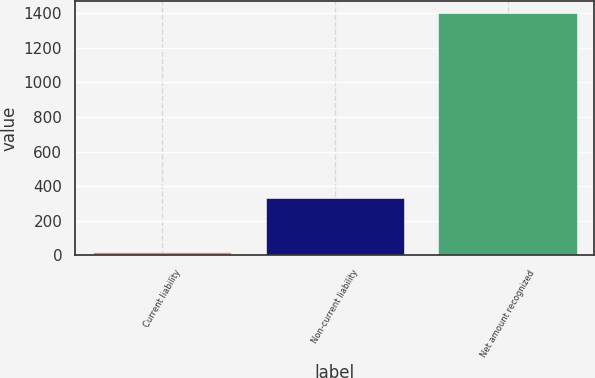Convert chart. <chart><loc_0><loc_0><loc_500><loc_500><bar_chart><fcel>Current liability<fcel>Non-current liability<fcel>Net amount recognized<nl><fcel>18<fcel>330<fcel>1403<nl></chart> 